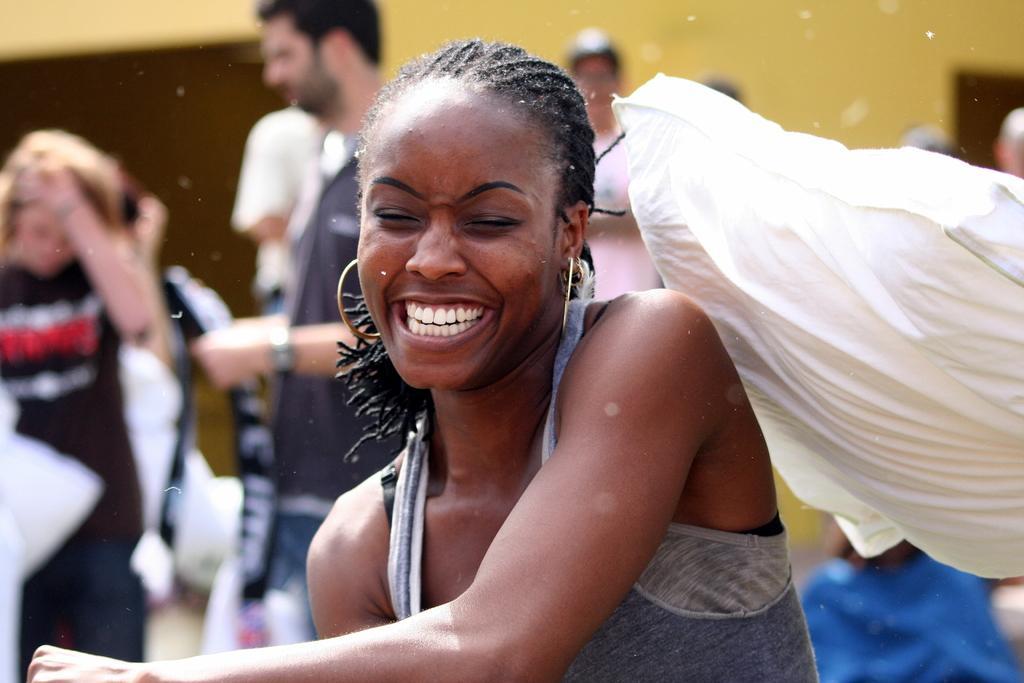In one or two sentences, can you explain what this image depicts? In this image I can see a woman sitting and laughing in the center of the image. I can see a pillow like object on the right side of the image and I can see some other people standing behind with a blurred background. 